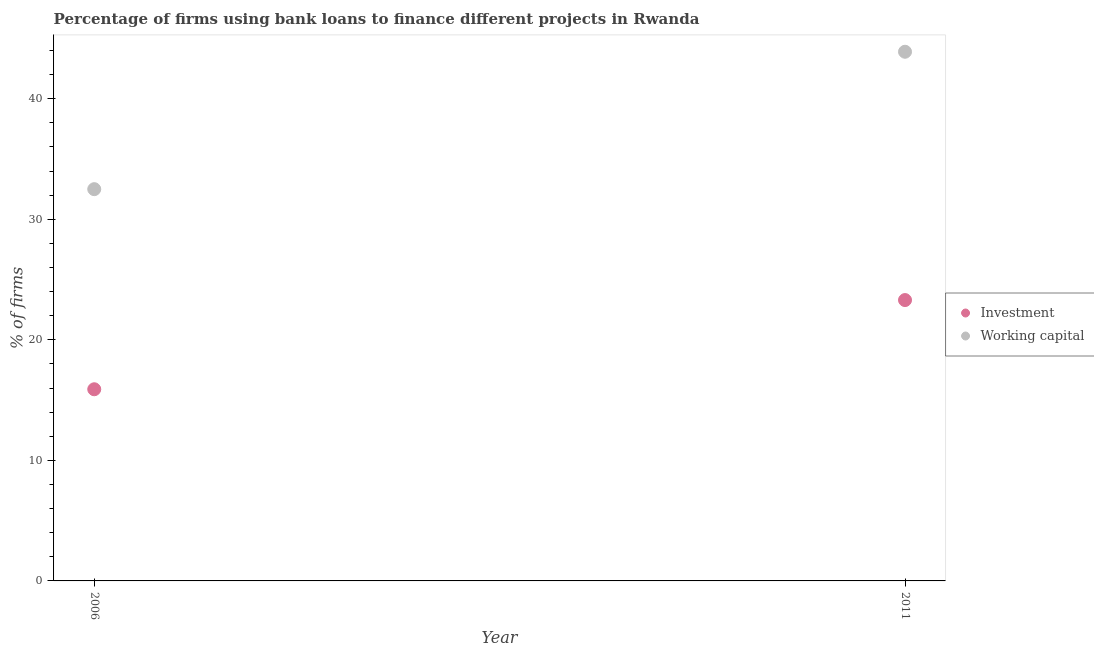How many different coloured dotlines are there?
Make the answer very short. 2. Is the number of dotlines equal to the number of legend labels?
Provide a short and direct response. Yes. Across all years, what is the maximum percentage of firms using banks to finance working capital?
Your answer should be compact. 43.9. Across all years, what is the minimum percentage of firms using banks to finance working capital?
Give a very brief answer. 32.5. In which year was the percentage of firms using banks to finance investment minimum?
Your answer should be very brief. 2006. What is the total percentage of firms using banks to finance working capital in the graph?
Offer a terse response. 76.4. What is the difference between the percentage of firms using banks to finance investment in 2006 and that in 2011?
Keep it short and to the point. -7.4. What is the average percentage of firms using banks to finance investment per year?
Provide a short and direct response. 19.6. In the year 2011, what is the difference between the percentage of firms using banks to finance investment and percentage of firms using banks to finance working capital?
Give a very brief answer. -20.6. What is the ratio of the percentage of firms using banks to finance investment in 2006 to that in 2011?
Give a very brief answer. 0.68. Is the percentage of firms using banks to finance working capital strictly greater than the percentage of firms using banks to finance investment over the years?
Make the answer very short. Yes. Is the percentage of firms using banks to finance working capital strictly less than the percentage of firms using banks to finance investment over the years?
Provide a succinct answer. No. How many dotlines are there?
Make the answer very short. 2. How many years are there in the graph?
Offer a terse response. 2. What is the difference between two consecutive major ticks on the Y-axis?
Your answer should be compact. 10. Are the values on the major ticks of Y-axis written in scientific E-notation?
Ensure brevity in your answer.  No. Does the graph contain any zero values?
Keep it short and to the point. No. Where does the legend appear in the graph?
Your response must be concise. Center right. How many legend labels are there?
Make the answer very short. 2. What is the title of the graph?
Your answer should be very brief. Percentage of firms using bank loans to finance different projects in Rwanda. What is the label or title of the X-axis?
Give a very brief answer. Year. What is the label or title of the Y-axis?
Offer a terse response. % of firms. What is the % of firms of Investment in 2006?
Ensure brevity in your answer.  15.9. What is the % of firms in Working capital in 2006?
Offer a terse response. 32.5. What is the % of firms of Investment in 2011?
Your answer should be very brief. 23.3. What is the % of firms in Working capital in 2011?
Your response must be concise. 43.9. Across all years, what is the maximum % of firms of Investment?
Make the answer very short. 23.3. Across all years, what is the maximum % of firms in Working capital?
Your answer should be very brief. 43.9. Across all years, what is the minimum % of firms of Working capital?
Make the answer very short. 32.5. What is the total % of firms in Investment in the graph?
Your answer should be very brief. 39.2. What is the total % of firms of Working capital in the graph?
Your answer should be very brief. 76.4. What is the difference between the % of firms in Investment in 2006 and that in 2011?
Ensure brevity in your answer.  -7.4. What is the difference between the % of firms of Working capital in 2006 and that in 2011?
Offer a terse response. -11.4. What is the average % of firms in Investment per year?
Offer a very short reply. 19.6. What is the average % of firms of Working capital per year?
Your answer should be very brief. 38.2. In the year 2006, what is the difference between the % of firms of Investment and % of firms of Working capital?
Give a very brief answer. -16.6. In the year 2011, what is the difference between the % of firms of Investment and % of firms of Working capital?
Your answer should be compact. -20.6. What is the ratio of the % of firms of Investment in 2006 to that in 2011?
Provide a succinct answer. 0.68. What is the ratio of the % of firms of Working capital in 2006 to that in 2011?
Give a very brief answer. 0.74. What is the difference between the highest and the second highest % of firms of Investment?
Keep it short and to the point. 7.4. What is the difference between the highest and the lowest % of firms of Investment?
Ensure brevity in your answer.  7.4. 